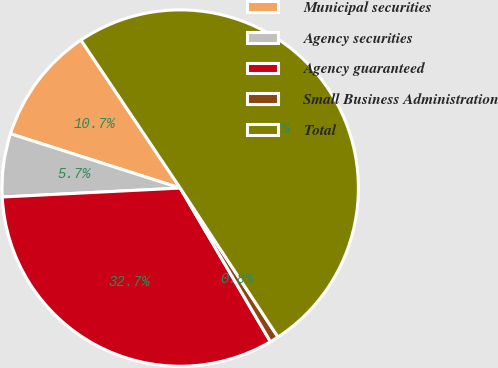Convert chart to OTSL. <chart><loc_0><loc_0><loc_500><loc_500><pie_chart><fcel>Municipal securities<fcel>Agency securities<fcel>Agency guaranteed<fcel>Small Business Administration<fcel>Total<nl><fcel>10.67%<fcel>5.73%<fcel>32.65%<fcel>0.79%<fcel>50.16%<nl></chart> 